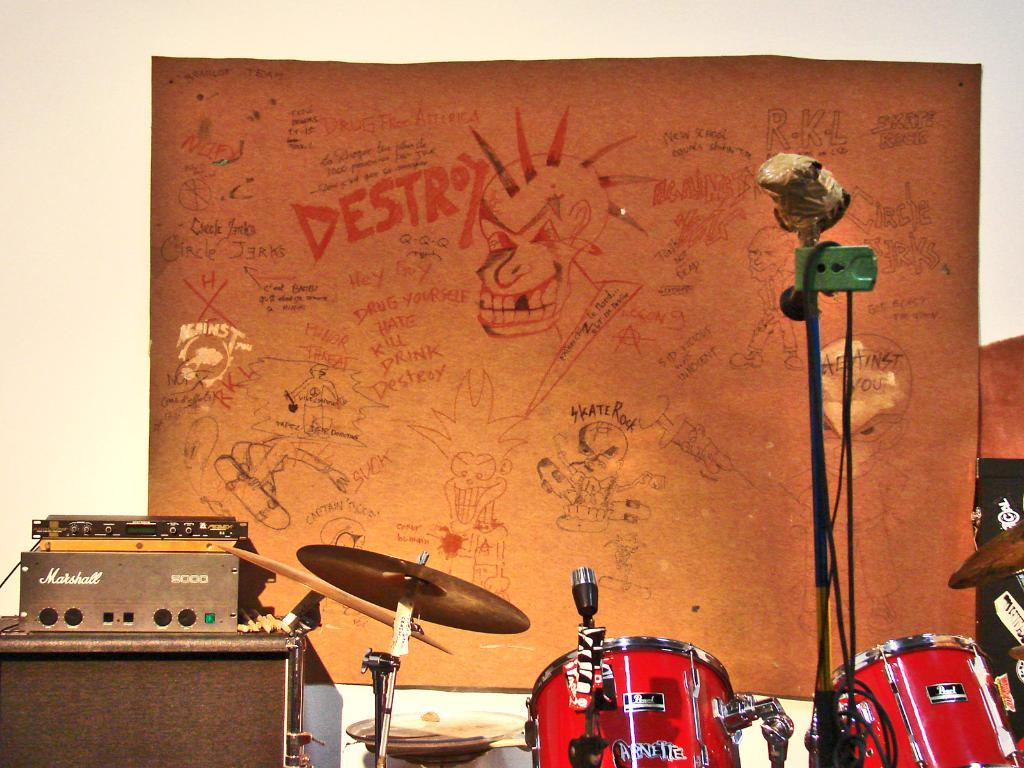<image>
Relay a brief, clear account of the picture shown. A red Bael drum set is sitting next to a mixer and amplifier. 